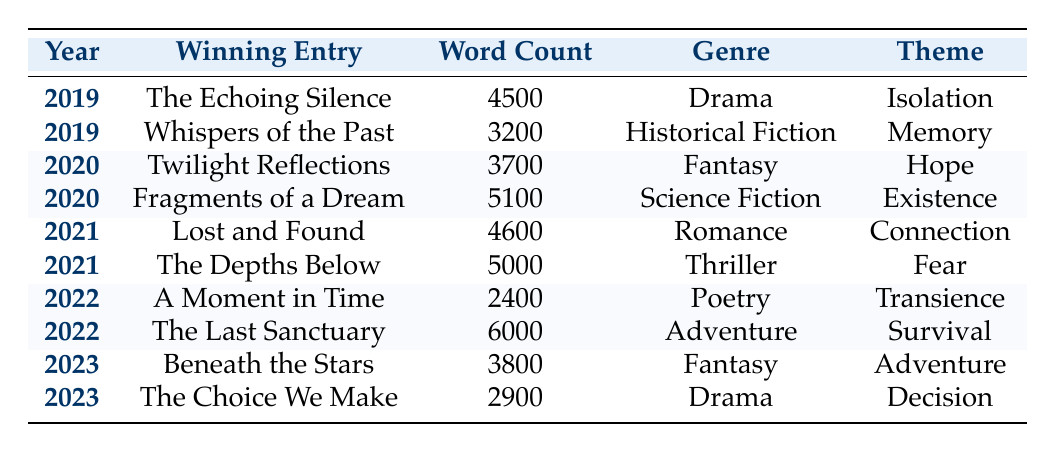What is the word count of the winning entry for 2021? The table shows the winning entries for the year 2021. The two entries are "Lost and Found" with a word count of 4600 and "The Depths Below" with a word count of 5000. Therefore, both entries have word counts listed.
Answer: 4600 and 5000 Which genre has the winning entry with the highest word count? The table lists the winning entries along with their genres and word counts. The entry with the highest word count is "The Last Sanctuary," which is in the Adventure genre with a word count of 6000.
Answer: Adventure What is the average word count of the winning entries from 2019? The winning entries from 2019 are "The Echoing Silence" with 4500 words and "Whispers of the Past" with 3200 words. The average word count is calculated by adding both (4500 + 3200 = 7700) and dividing by 2 (7700 / 2 = 3850).
Answer: 3850 Did any winning entries have a word count below 3000? The entries listed in the table do not show any winning entries with a word count below 3000. The lowest word count is 2400, which belongs to "A Moment in Time," making it false that there are any below 3000.
Answer: No What is the trend in word counts from 2019 to 2023? To analyze the trend, we consider the winning entries for each year. The word counts are as follows: 2019 - 4500 and 3200, 2020 - 3700 and 5100, 2021 - 4600 and 5000, 2022 - 2400 and 6000, and 2023 - 3800 and 2900. There are fluctuations, with increasing counts in some years and a significant drop in 2022, indicating no clear trend.
Answer: No clear trend 